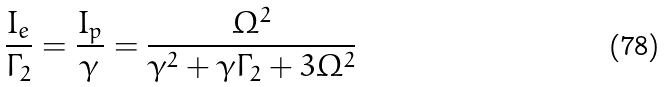Convert formula to latex. <formula><loc_0><loc_0><loc_500><loc_500>\frac { I _ { e } } { \Gamma _ { 2 } } = \frac { I _ { p } } { \gamma } = \frac { \Omega ^ { 2 } } { \gamma ^ { 2 } + \gamma \Gamma _ { 2 } + 3 \Omega ^ { 2 } }</formula> 